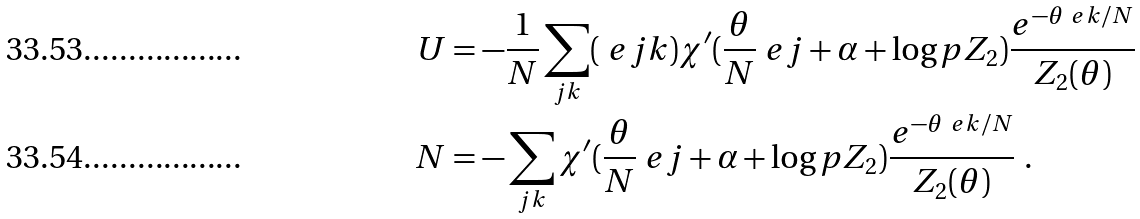Convert formula to latex. <formula><loc_0><loc_0><loc_500><loc_500>U & = - \frac { 1 } { N } \sum _ { j k } ( \ e j k ) \chi ^ { \prime } ( \frac { \theta } N \ e j + \alpha + \log p Z _ { 2 } ) \frac { e ^ { - \theta \ e k / N } } { Z _ { 2 } ( \theta ) } \\ N & = - \sum _ { j k } \chi ^ { \prime } ( \frac { \theta } N \ e j + \alpha + \log p Z _ { 2 } ) \frac { e ^ { - \theta \ e k / N } } { Z _ { 2 } ( \theta ) } \ .</formula> 